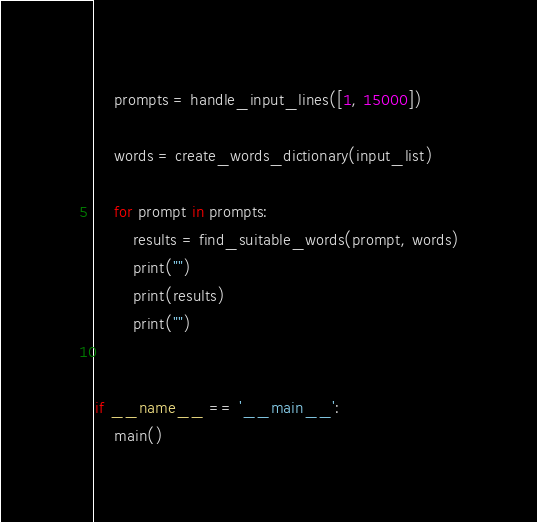<code> <loc_0><loc_0><loc_500><loc_500><_Python_>    prompts = handle_input_lines([1, 15000])

    words = create_words_dictionary(input_list)

    for prompt in prompts:
        results = find_suitable_words(prompt, words)
        print("")
        print(results)
        print("")


if __name__ == '__main__':
    main()
</code> 